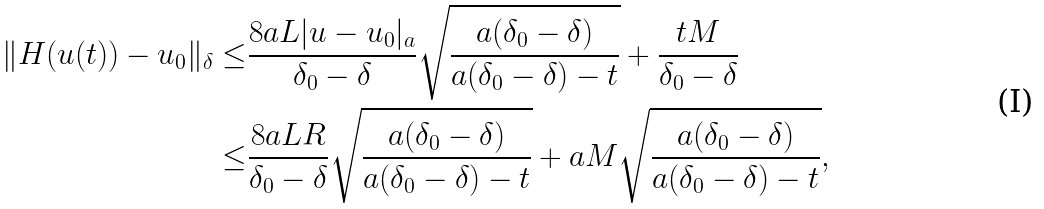Convert formula to latex. <formula><loc_0><loc_0><loc_500><loc_500>\| H ( u ( t ) ) - u _ { 0 } \| _ { \delta } \leq & \frac { 8 a L | u - u _ { 0 } | _ { a } } { \delta _ { 0 } - \delta } \sqrt { \frac { a ( \delta _ { 0 } - \delta ) } { a ( \delta _ { 0 } - \delta ) - t } } + \frac { t M } { \delta _ { 0 } - \delta } \\ \leq & \frac { 8 a L R } { \delta _ { 0 } - \delta } \sqrt { \frac { a ( \delta _ { 0 } - \delta ) } { a ( \delta _ { 0 } - \delta ) - t } } + a M \sqrt { \frac { a ( \delta _ { 0 } - \delta ) } { a ( \delta _ { 0 } - \delta ) - t } } ,</formula> 